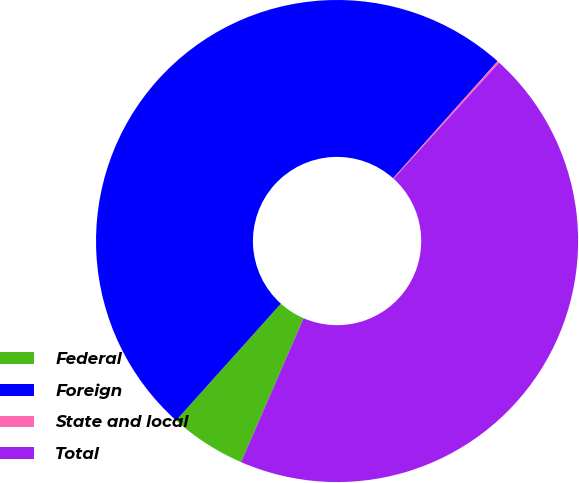<chart> <loc_0><loc_0><loc_500><loc_500><pie_chart><fcel>Federal<fcel>Foreign<fcel>State and local<fcel>Total<nl><fcel>5.12%<fcel>49.96%<fcel>0.14%<fcel>44.78%<nl></chart> 